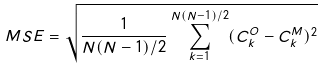Convert formula to latex. <formula><loc_0><loc_0><loc_500><loc_500>M S E = \sqrt { \frac { 1 } { N ( N - 1 ) / 2 } \sum _ { k = 1 } ^ { N ( N - 1 ) / 2 } ( C _ { k } ^ { O } - C _ { k } ^ { M } ) ^ { 2 } }</formula> 